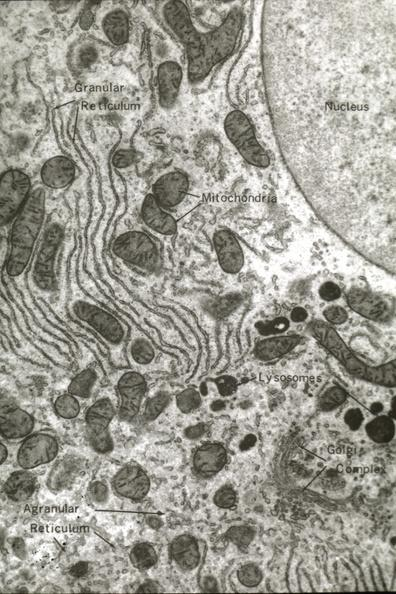what labeled?
Answer the question using a single word or phrase. Structures 